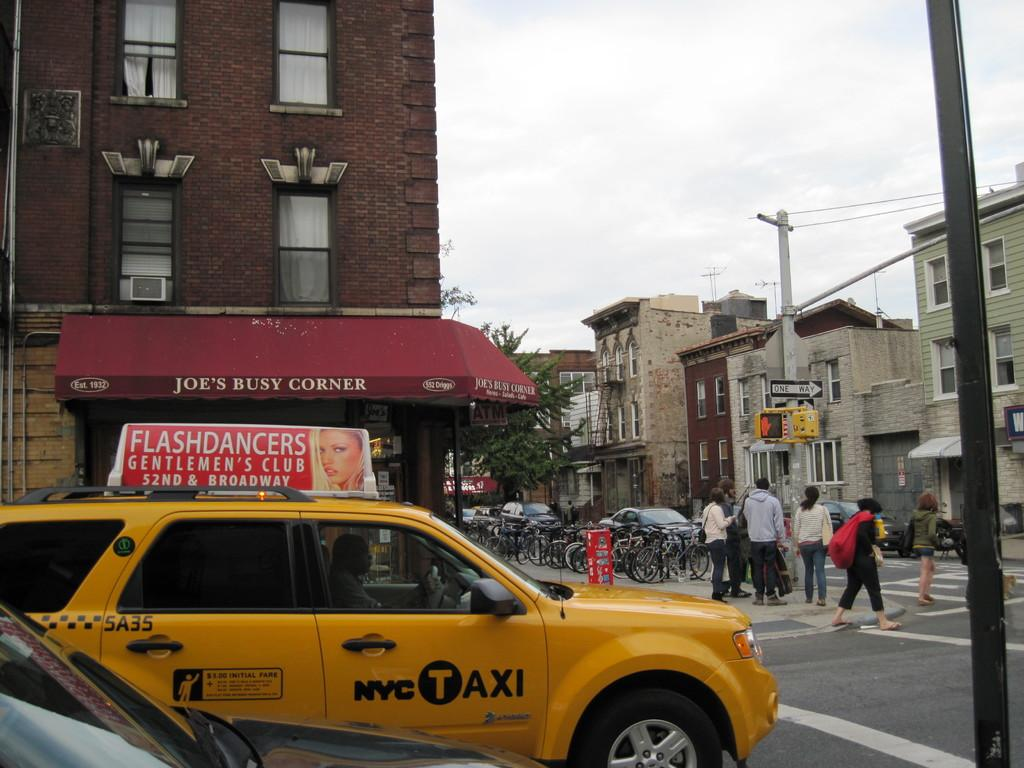Provide a one-sentence caption for the provided image. New york city taxi cab is parked near a car while walkers cross the road. 